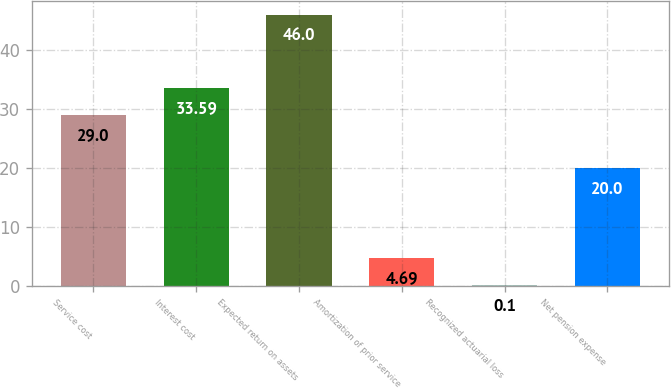<chart> <loc_0><loc_0><loc_500><loc_500><bar_chart><fcel>Service cost<fcel>Interest cost<fcel>Expected return on assets<fcel>Amortization of prior service<fcel>Recognized actuarial loss<fcel>Net pension expense<nl><fcel>29<fcel>33.59<fcel>46<fcel>4.69<fcel>0.1<fcel>20<nl></chart> 